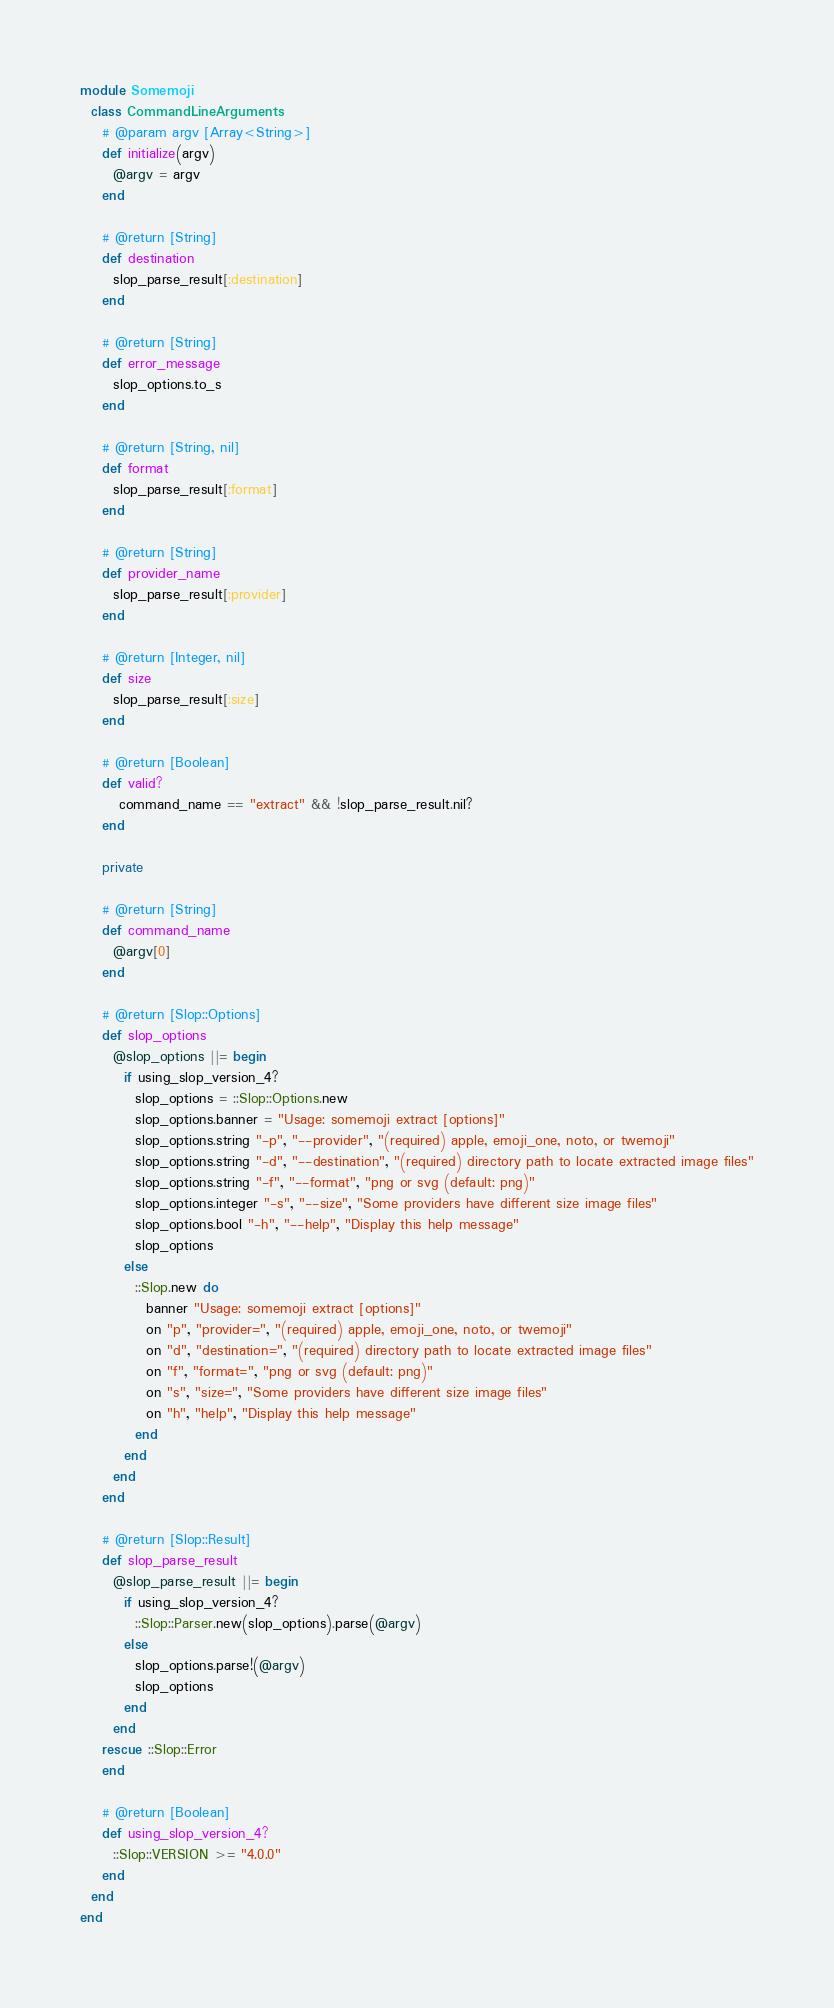<code> <loc_0><loc_0><loc_500><loc_500><_Ruby_>module Somemoji
  class CommandLineArguments
    # @param argv [Array<String>]
    def initialize(argv)
      @argv = argv
    end

    # @return [String]
    def destination
      slop_parse_result[:destination]
    end

    # @return [String]
    def error_message
      slop_options.to_s
    end

    # @return [String, nil]
    def format
      slop_parse_result[:format]
    end

    # @return [String]
    def provider_name
      slop_parse_result[:provider]
    end

    # @return [Integer, nil]
    def size
      slop_parse_result[:size]
    end

    # @return [Boolean]
    def valid?
       command_name == "extract" && !slop_parse_result.nil?
    end

    private

    # @return [String]
    def command_name
      @argv[0]
    end

    # @return [Slop::Options]
    def slop_options
      @slop_options ||= begin
        if using_slop_version_4?
          slop_options = ::Slop::Options.new
          slop_options.banner = "Usage: somemoji extract [options]"
          slop_options.string "-p", "--provider", "(required) apple, emoji_one, noto, or twemoji"
          slop_options.string "-d", "--destination", "(required) directory path to locate extracted image files"
          slop_options.string "-f", "--format", "png or svg (default: png)"
          slop_options.integer "-s", "--size", "Some providers have different size image files"
          slop_options.bool "-h", "--help", "Display this help message"
          slop_options
        else
          ::Slop.new do
            banner "Usage: somemoji extract [options]"
            on "p", "provider=", "(required) apple, emoji_one, noto, or twemoji"
            on "d", "destination=", "(required) directory path to locate extracted image files"
            on "f", "format=", "png or svg (default: png)"
            on "s", "size=", "Some providers have different size image files"
            on "h", "help", "Display this help message"
          end
        end
      end
    end

    # @return [Slop::Result]
    def slop_parse_result
      @slop_parse_result ||= begin
        if using_slop_version_4?
          ::Slop::Parser.new(slop_options).parse(@argv)
        else
          slop_options.parse!(@argv)
          slop_options
        end
      end
    rescue ::Slop::Error
    end

    # @return [Boolean]
    def using_slop_version_4?
      ::Slop::VERSION >= "4.0.0"
    end
  end
end
</code> 